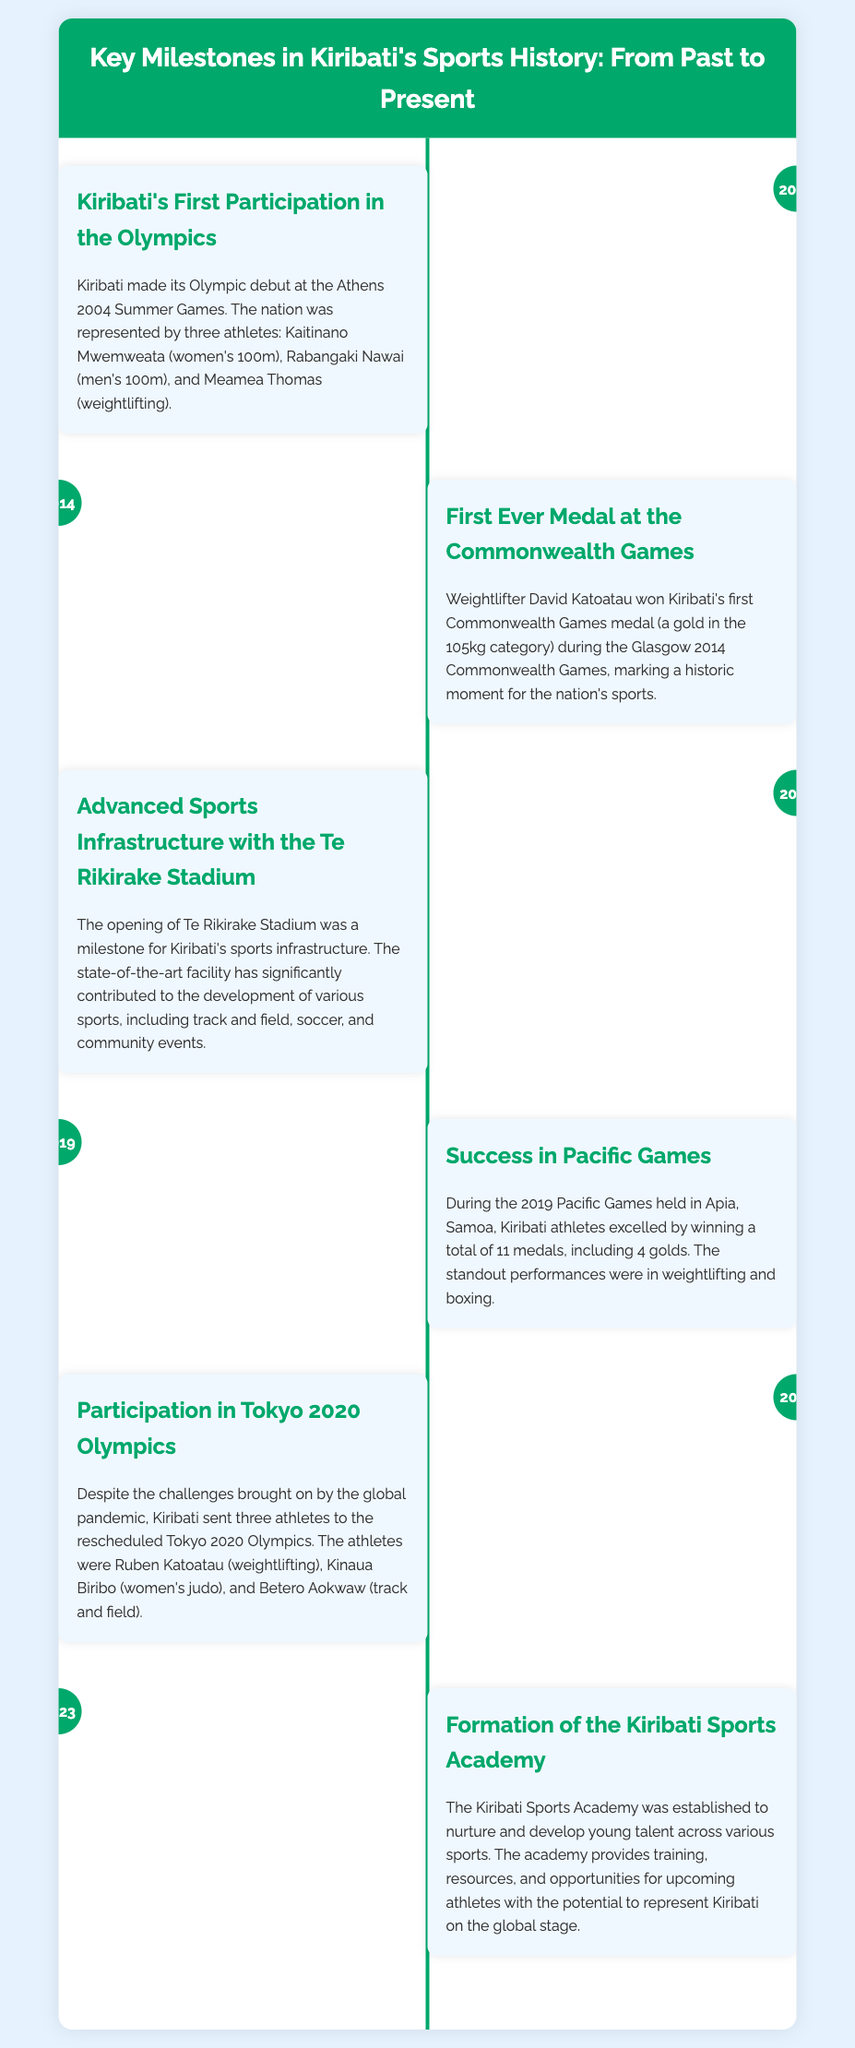What year did Kiribati first participate in the Olympics? Kiribati made its Olympic debut at the Athens 2004 Summer Games.
Answer: 2004 Who won Kiribati's first Commonwealth Games medal? Weightlifter David Katoatau won the gold medal during the Glasgow 2014 Commonwealth Games.
Answer: David Katoatau What major sport facility opened in Kiribati in 2016? The opening of Te Rikirake Stadium was a significant milestone for sports infrastructure.
Answer: Te Rikirake Stadium How many medals did Kiribati win at the 2019 Pacific Games? Kiribati athletes excelled by winning a total of 11 medals at the 2019 Pacific Games.
Answer: 11 medals What was established in 2023 to develop young talent in Kiribati? The Kiribati Sports Academy was established to nurture and develop young talent across various sports.
Answer: Kiribati Sports Academy Which Olympic event did Ruben Katoatau participate in 2021? Ruben Katoatau represented Kiribati in weightlifting at the Tokyo 2020 Olympics.
Answer: Weightlifting What category did David Katoatau win gold in at the Commonwealth Games? David Katoatau won gold in the 105kg weightlifting category.
Answer: 105kg In which city were the 2019 Pacific Games held? The 2019 Pacific Games were held in Apia, Samoa.
Answer: Apia, Samoa 